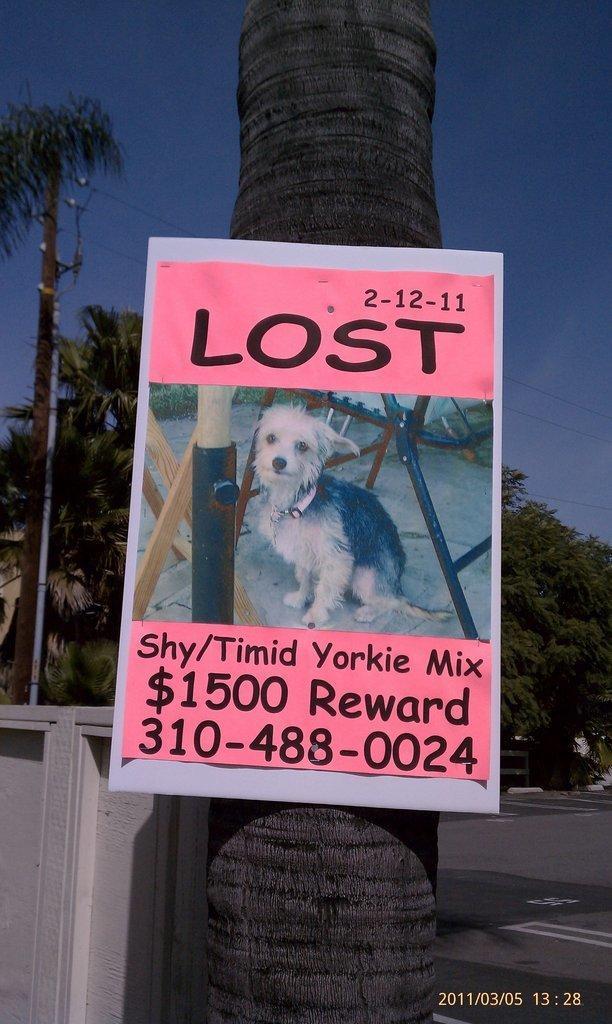Could you give a brief overview of what you see in this image? In this picture I can see poster attached to the tree. On the poster I can see a dog and something written on it. In the background I can see trees and the sky. I can also see a pole which has wires attached to it. 